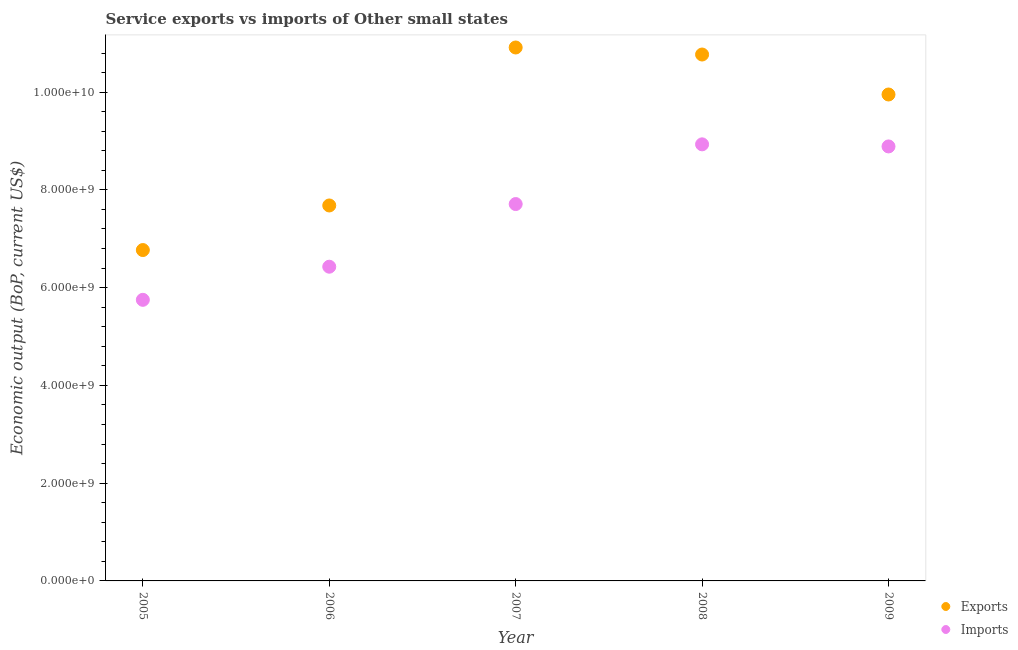Is the number of dotlines equal to the number of legend labels?
Make the answer very short. Yes. What is the amount of service exports in 2006?
Provide a succinct answer. 7.68e+09. Across all years, what is the maximum amount of service imports?
Offer a terse response. 8.93e+09. Across all years, what is the minimum amount of service imports?
Keep it short and to the point. 5.75e+09. In which year was the amount of service imports maximum?
Offer a very short reply. 2008. In which year was the amount of service exports minimum?
Your response must be concise. 2005. What is the total amount of service exports in the graph?
Your answer should be compact. 4.61e+1. What is the difference between the amount of service exports in 2006 and that in 2007?
Make the answer very short. -3.23e+09. What is the difference between the amount of service exports in 2009 and the amount of service imports in 2005?
Your answer should be compact. 4.20e+09. What is the average amount of service exports per year?
Make the answer very short. 9.22e+09. In the year 2008, what is the difference between the amount of service imports and amount of service exports?
Offer a very short reply. -1.84e+09. In how many years, is the amount of service imports greater than 3600000000 US$?
Give a very brief answer. 5. What is the ratio of the amount of service imports in 2005 to that in 2008?
Make the answer very short. 0.64. Is the difference between the amount of service imports in 2005 and 2009 greater than the difference between the amount of service exports in 2005 and 2009?
Ensure brevity in your answer.  Yes. What is the difference between the highest and the second highest amount of service exports?
Make the answer very short. 1.44e+08. What is the difference between the highest and the lowest amount of service exports?
Provide a succinct answer. 4.14e+09. Is the sum of the amount of service exports in 2007 and 2008 greater than the maximum amount of service imports across all years?
Give a very brief answer. Yes. Does the amount of service exports monotonically increase over the years?
Make the answer very short. No. How many dotlines are there?
Offer a terse response. 2. How many years are there in the graph?
Keep it short and to the point. 5. What is the difference between two consecutive major ticks on the Y-axis?
Provide a short and direct response. 2.00e+09. Are the values on the major ticks of Y-axis written in scientific E-notation?
Keep it short and to the point. Yes. Does the graph contain any zero values?
Your answer should be compact. No. How many legend labels are there?
Provide a short and direct response. 2. How are the legend labels stacked?
Keep it short and to the point. Vertical. What is the title of the graph?
Provide a short and direct response. Service exports vs imports of Other small states. Does "Stunting" appear as one of the legend labels in the graph?
Make the answer very short. No. What is the label or title of the X-axis?
Give a very brief answer. Year. What is the label or title of the Y-axis?
Make the answer very short. Economic output (BoP, current US$). What is the Economic output (BoP, current US$) in Exports in 2005?
Ensure brevity in your answer.  6.77e+09. What is the Economic output (BoP, current US$) in Imports in 2005?
Make the answer very short. 5.75e+09. What is the Economic output (BoP, current US$) of Exports in 2006?
Keep it short and to the point. 7.68e+09. What is the Economic output (BoP, current US$) of Imports in 2006?
Offer a very short reply. 6.43e+09. What is the Economic output (BoP, current US$) in Exports in 2007?
Ensure brevity in your answer.  1.09e+1. What is the Economic output (BoP, current US$) in Imports in 2007?
Ensure brevity in your answer.  7.71e+09. What is the Economic output (BoP, current US$) of Exports in 2008?
Ensure brevity in your answer.  1.08e+1. What is the Economic output (BoP, current US$) in Imports in 2008?
Give a very brief answer. 8.93e+09. What is the Economic output (BoP, current US$) of Exports in 2009?
Your response must be concise. 9.95e+09. What is the Economic output (BoP, current US$) in Imports in 2009?
Your answer should be compact. 8.89e+09. Across all years, what is the maximum Economic output (BoP, current US$) in Exports?
Your answer should be very brief. 1.09e+1. Across all years, what is the maximum Economic output (BoP, current US$) of Imports?
Your response must be concise. 8.93e+09. Across all years, what is the minimum Economic output (BoP, current US$) of Exports?
Provide a succinct answer. 6.77e+09. Across all years, what is the minimum Economic output (BoP, current US$) in Imports?
Provide a succinct answer. 5.75e+09. What is the total Economic output (BoP, current US$) of Exports in the graph?
Your response must be concise. 4.61e+1. What is the total Economic output (BoP, current US$) of Imports in the graph?
Offer a very short reply. 3.77e+1. What is the difference between the Economic output (BoP, current US$) of Exports in 2005 and that in 2006?
Offer a terse response. -9.12e+08. What is the difference between the Economic output (BoP, current US$) in Imports in 2005 and that in 2006?
Your answer should be very brief. -6.78e+08. What is the difference between the Economic output (BoP, current US$) of Exports in 2005 and that in 2007?
Ensure brevity in your answer.  -4.14e+09. What is the difference between the Economic output (BoP, current US$) in Imports in 2005 and that in 2007?
Make the answer very short. -1.96e+09. What is the difference between the Economic output (BoP, current US$) of Exports in 2005 and that in 2008?
Keep it short and to the point. -4.00e+09. What is the difference between the Economic output (BoP, current US$) of Imports in 2005 and that in 2008?
Your response must be concise. -3.18e+09. What is the difference between the Economic output (BoP, current US$) of Exports in 2005 and that in 2009?
Your answer should be compact. -3.18e+09. What is the difference between the Economic output (BoP, current US$) of Imports in 2005 and that in 2009?
Provide a succinct answer. -3.14e+09. What is the difference between the Economic output (BoP, current US$) in Exports in 2006 and that in 2007?
Your response must be concise. -3.23e+09. What is the difference between the Economic output (BoP, current US$) of Imports in 2006 and that in 2007?
Provide a succinct answer. -1.28e+09. What is the difference between the Economic output (BoP, current US$) in Exports in 2006 and that in 2008?
Make the answer very short. -3.09e+09. What is the difference between the Economic output (BoP, current US$) of Imports in 2006 and that in 2008?
Provide a succinct answer. -2.50e+09. What is the difference between the Economic output (BoP, current US$) in Exports in 2006 and that in 2009?
Ensure brevity in your answer.  -2.27e+09. What is the difference between the Economic output (BoP, current US$) in Imports in 2006 and that in 2009?
Offer a terse response. -2.46e+09. What is the difference between the Economic output (BoP, current US$) in Exports in 2007 and that in 2008?
Your response must be concise. 1.44e+08. What is the difference between the Economic output (BoP, current US$) in Imports in 2007 and that in 2008?
Keep it short and to the point. -1.22e+09. What is the difference between the Economic output (BoP, current US$) of Exports in 2007 and that in 2009?
Offer a terse response. 9.62e+08. What is the difference between the Economic output (BoP, current US$) in Imports in 2007 and that in 2009?
Your response must be concise. -1.18e+09. What is the difference between the Economic output (BoP, current US$) of Exports in 2008 and that in 2009?
Make the answer very short. 8.18e+08. What is the difference between the Economic output (BoP, current US$) in Imports in 2008 and that in 2009?
Keep it short and to the point. 4.27e+07. What is the difference between the Economic output (BoP, current US$) of Exports in 2005 and the Economic output (BoP, current US$) of Imports in 2006?
Keep it short and to the point. 3.41e+08. What is the difference between the Economic output (BoP, current US$) in Exports in 2005 and the Economic output (BoP, current US$) in Imports in 2007?
Give a very brief answer. -9.41e+08. What is the difference between the Economic output (BoP, current US$) of Exports in 2005 and the Economic output (BoP, current US$) of Imports in 2008?
Give a very brief answer. -2.16e+09. What is the difference between the Economic output (BoP, current US$) in Exports in 2005 and the Economic output (BoP, current US$) in Imports in 2009?
Your answer should be compact. -2.12e+09. What is the difference between the Economic output (BoP, current US$) in Exports in 2006 and the Economic output (BoP, current US$) in Imports in 2007?
Keep it short and to the point. -2.90e+07. What is the difference between the Economic output (BoP, current US$) in Exports in 2006 and the Economic output (BoP, current US$) in Imports in 2008?
Your answer should be compact. -1.25e+09. What is the difference between the Economic output (BoP, current US$) of Exports in 2006 and the Economic output (BoP, current US$) of Imports in 2009?
Provide a succinct answer. -1.21e+09. What is the difference between the Economic output (BoP, current US$) of Exports in 2007 and the Economic output (BoP, current US$) of Imports in 2008?
Offer a terse response. 1.98e+09. What is the difference between the Economic output (BoP, current US$) in Exports in 2007 and the Economic output (BoP, current US$) in Imports in 2009?
Provide a short and direct response. 2.02e+09. What is the difference between the Economic output (BoP, current US$) in Exports in 2008 and the Economic output (BoP, current US$) in Imports in 2009?
Your answer should be very brief. 1.88e+09. What is the average Economic output (BoP, current US$) in Exports per year?
Offer a terse response. 9.22e+09. What is the average Economic output (BoP, current US$) in Imports per year?
Your answer should be compact. 7.54e+09. In the year 2005, what is the difference between the Economic output (BoP, current US$) in Exports and Economic output (BoP, current US$) in Imports?
Provide a short and direct response. 1.02e+09. In the year 2006, what is the difference between the Economic output (BoP, current US$) of Exports and Economic output (BoP, current US$) of Imports?
Give a very brief answer. 1.25e+09. In the year 2007, what is the difference between the Economic output (BoP, current US$) of Exports and Economic output (BoP, current US$) of Imports?
Make the answer very short. 3.20e+09. In the year 2008, what is the difference between the Economic output (BoP, current US$) in Exports and Economic output (BoP, current US$) in Imports?
Your response must be concise. 1.84e+09. In the year 2009, what is the difference between the Economic output (BoP, current US$) of Exports and Economic output (BoP, current US$) of Imports?
Offer a terse response. 1.06e+09. What is the ratio of the Economic output (BoP, current US$) of Exports in 2005 to that in 2006?
Your answer should be very brief. 0.88. What is the ratio of the Economic output (BoP, current US$) of Imports in 2005 to that in 2006?
Provide a short and direct response. 0.89. What is the ratio of the Economic output (BoP, current US$) of Exports in 2005 to that in 2007?
Your answer should be very brief. 0.62. What is the ratio of the Economic output (BoP, current US$) of Imports in 2005 to that in 2007?
Your response must be concise. 0.75. What is the ratio of the Economic output (BoP, current US$) in Exports in 2005 to that in 2008?
Offer a very short reply. 0.63. What is the ratio of the Economic output (BoP, current US$) of Imports in 2005 to that in 2008?
Ensure brevity in your answer.  0.64. What is the ratio of the Economic output (BoP, current US$) of Exports in 2005 to that in 2009?
Provide a succinct answer. 0.68. What is the ratio of the Economic output (BoP, current US$) of Imports in 2005 to that in 2009?
Offer a very short reply. 0.65. What is the ratio of the Economic output (BoP, current US$) of Exports in 2006 to that in 2007?
Offer a very short reply. 0.7. What is the ratio of the Economic output (BoP, current US$) of Imports in 2006 to that in 2007?
Your answer should be very brief. 0.83. What is the ratio of the Economic output (BoP, current US$) of Exports in 2006 to that in 2008?
Ensure brevity in your answer.  0.71. What is the ratio of the Economic output (BoP, current US$) in Imports in 2006 to that in 2008?
Provide a succinct answer. 0.72. What is the ratio of the Economic output (BoP, current US$) in Exports in 2006 to that in 2009?
Provide a succinct answer. 0.77. What is the ratio of the Economic output (BoP, current US$) of Imports in 2006 to that in 2009?
Keep it short and to the point. 0.72. What is the ratio of the Economic output (BoP, current US$) of Exports in 2007 to that in 2008?
Make the answer very short. 1.01. What is the ratio of the Economic output (BoP, current US$) of Imports in 2007 to that in 2008?
Your response must be concise. 0.86. What is the ratio of the Economic output (BoP, current US$) in Exports in 2007 to that in 2009?
Provide a short and direct response. 1.1. What is the ratio of the Economic output (BoP, current US$) of Imports in 2007 to that in 2009?
Keep it short and to the point. 0.87. What is the ratio of the Economic output (BoP, current US$) in Exports in 2008 to that in 2009?
Your answer should be compact. 1.08. What is the ratio of the Economic output (BoP, current US$) of Imports in 2008 to that in 2009?
Provide a succinct answer. 1. What is the difference between the highest and the second highest Economic output (BoP, current US$) in Exports?
Give a very brief answer. 1.44e+08. What is the difference between the highest and the second highest Economic output (BoP, current US$) in Imports?
Your answer should be compact. 4.27e+07. What is the difference between the highest and the lowest Economic output (BoP, current US$) of Exports?
Provide a succinct answer. 4.14e+09. What is the difference between the highest and the lowest Economic output (BoP, current US$) of Imports?
Offer a very short reply. 3.18e+09. 